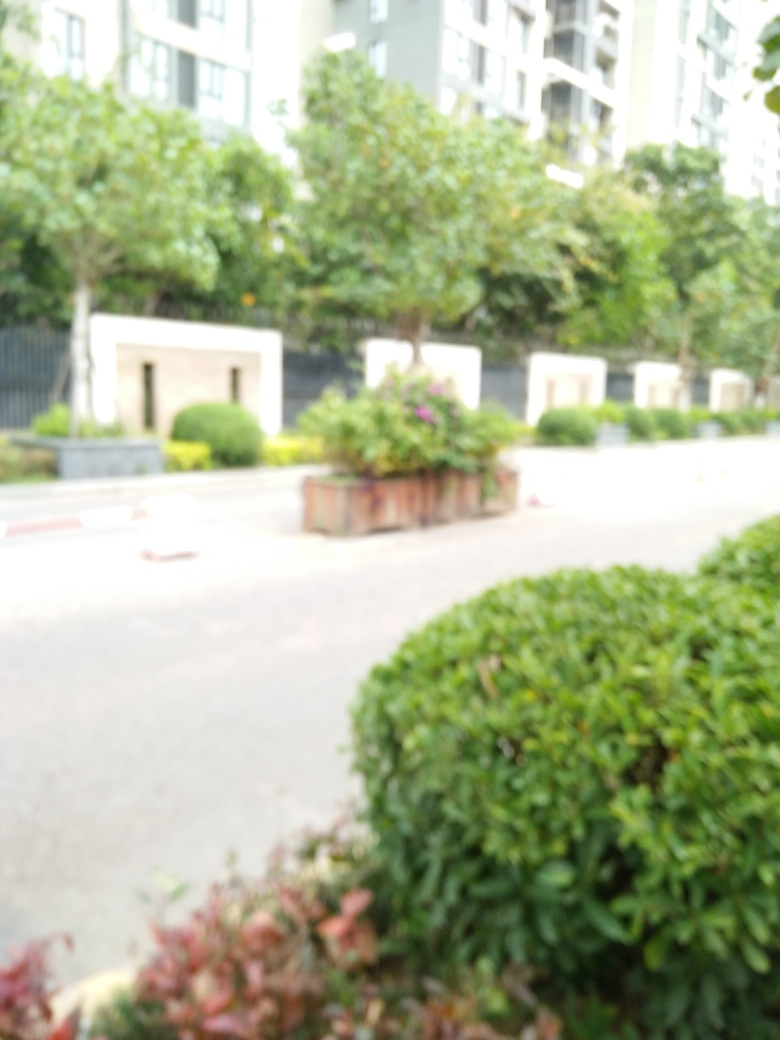What is the issue with this image? The main issue with this image is its serious focusing problems. Everything appears blurred, with no particular area in sharp focus, which suggests an issue with the camera's autofocus setting or a possible unintentional movement during the shot. This affects the clarity and detail that can be discerned, making it difficult to fully appreciate the subjects of the photo, such as the plants and architectural features visible. 